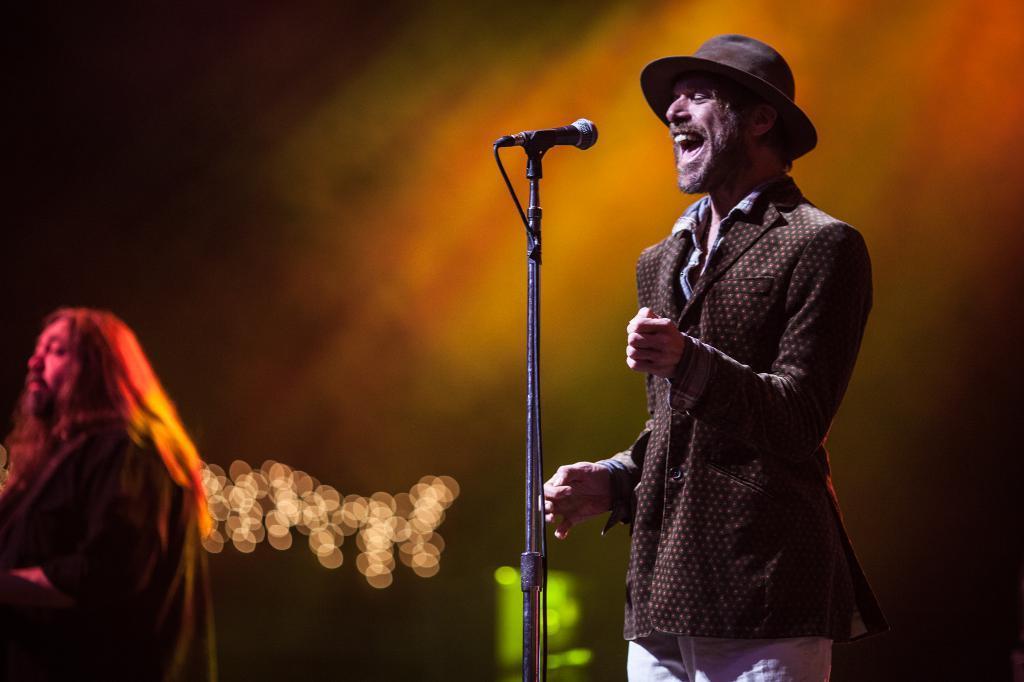How would you summarize this image in a sentence or two? As we can see in the image there are two people and a mic. In the background there are lights and the background is blurred. 